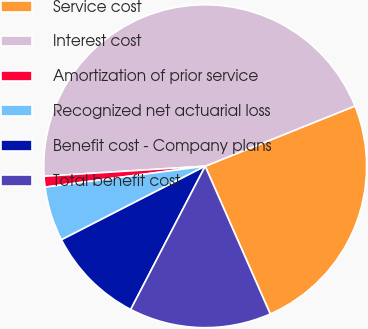Convert chart. <chart><loc_0><loc_0><loc_500><loc_500><pie_chart><fcel>Service cost<fcel>Interest cost<fcel>Amortization of prior service<fcel>Recognized net actuarial loss<fcel>Benefit cost - Company plans<fcel>Total benefit cost<nl><fcel>24.48%<fcel>44.91%<fcel>1.08%<fcel>5.46%<fcel>9.84%<fcel>14.23%<nl></chart> 